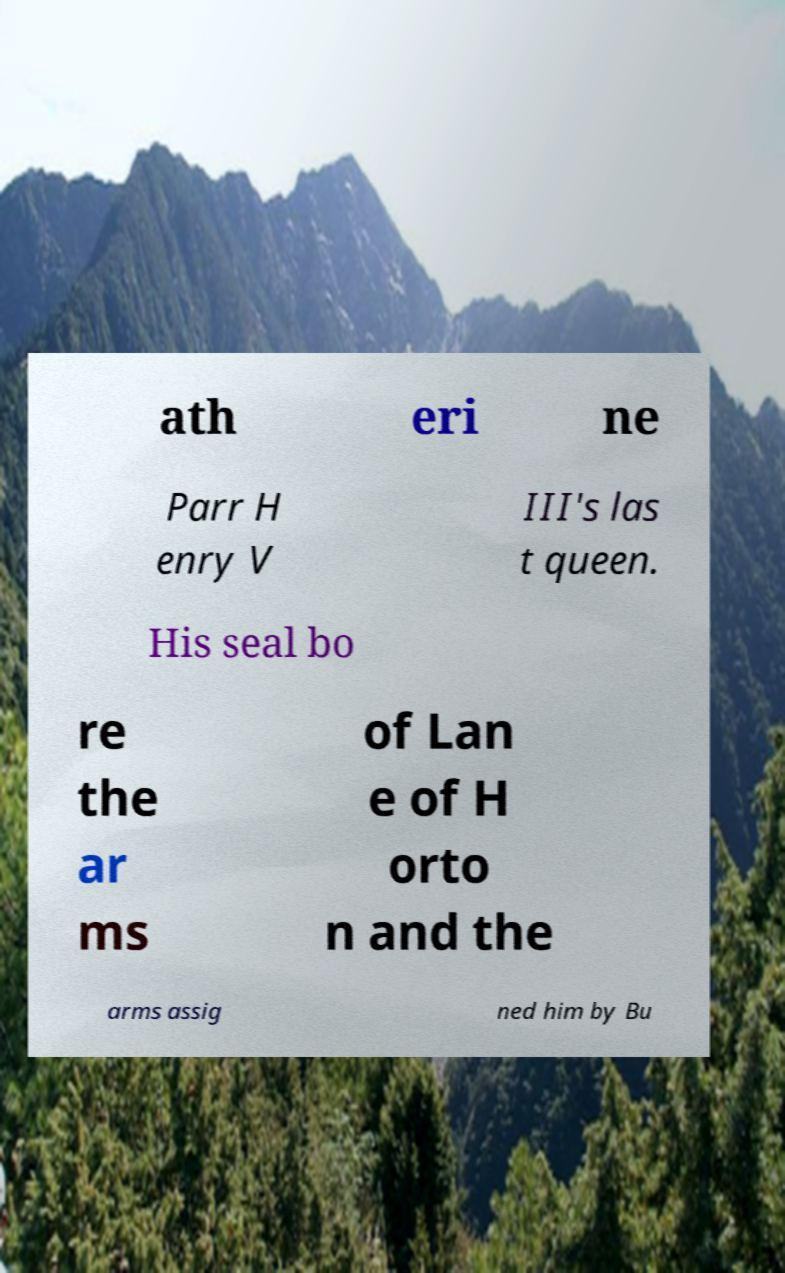What messages or text are displayed in this image? I need them in a readable, typed format. ath eri ne Parr H enry V III's las t queen. His seal bo re the ar ms of Lan e of H orto n and the arms assig ned him by Bu 